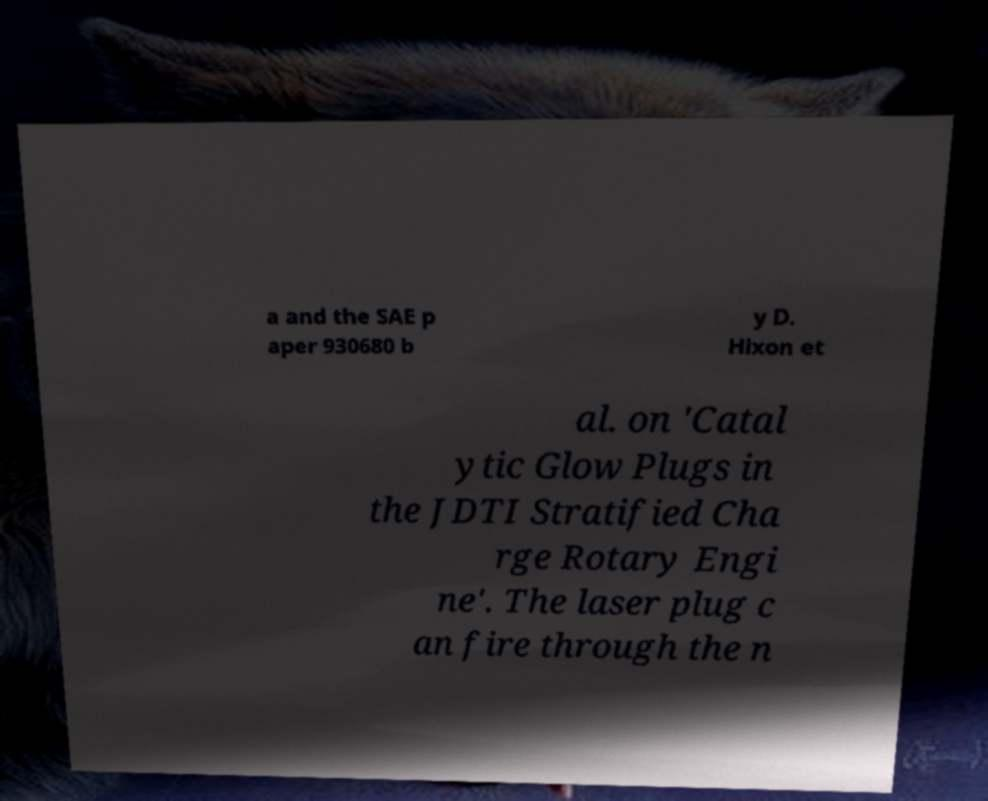Please read and relay the text visible in this image. What does it say? a and the SAE p aper 930680 b y D. Hixon et al. on 'Catal ytic Glow Plugs in the JDTI Stratified Cha rge Rotary Engi ne'. The laser plug c an fire through the n 